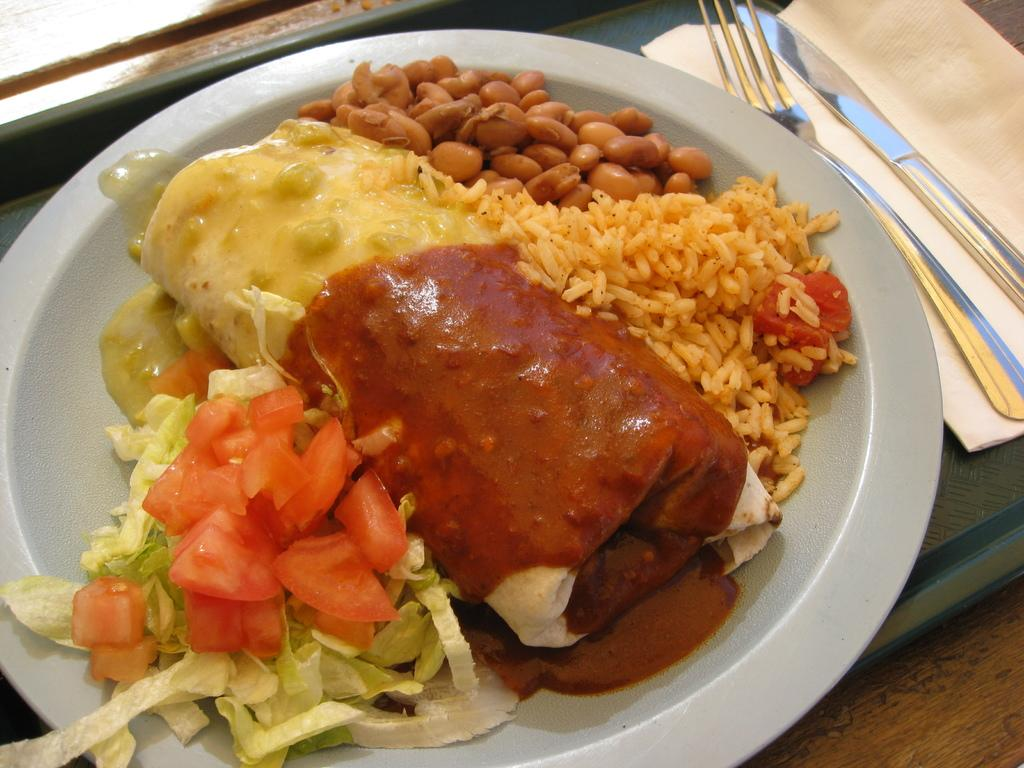What is on the plate that is visible in the image? The plate contains cut vegetables, rice, chapati, sauce, and groundnut. How are the items on the plate arranged? The items on the plate are arranged in a tray. Where is the tray located? The tray is on a table. Can you describe the setting where the tray is located? The image may have been taken in a room. Can you hear the rhythm of the snake slithering in the image? There is no snake or rhythm present in the image; it features a plate of food arranged in a tray on a table. 